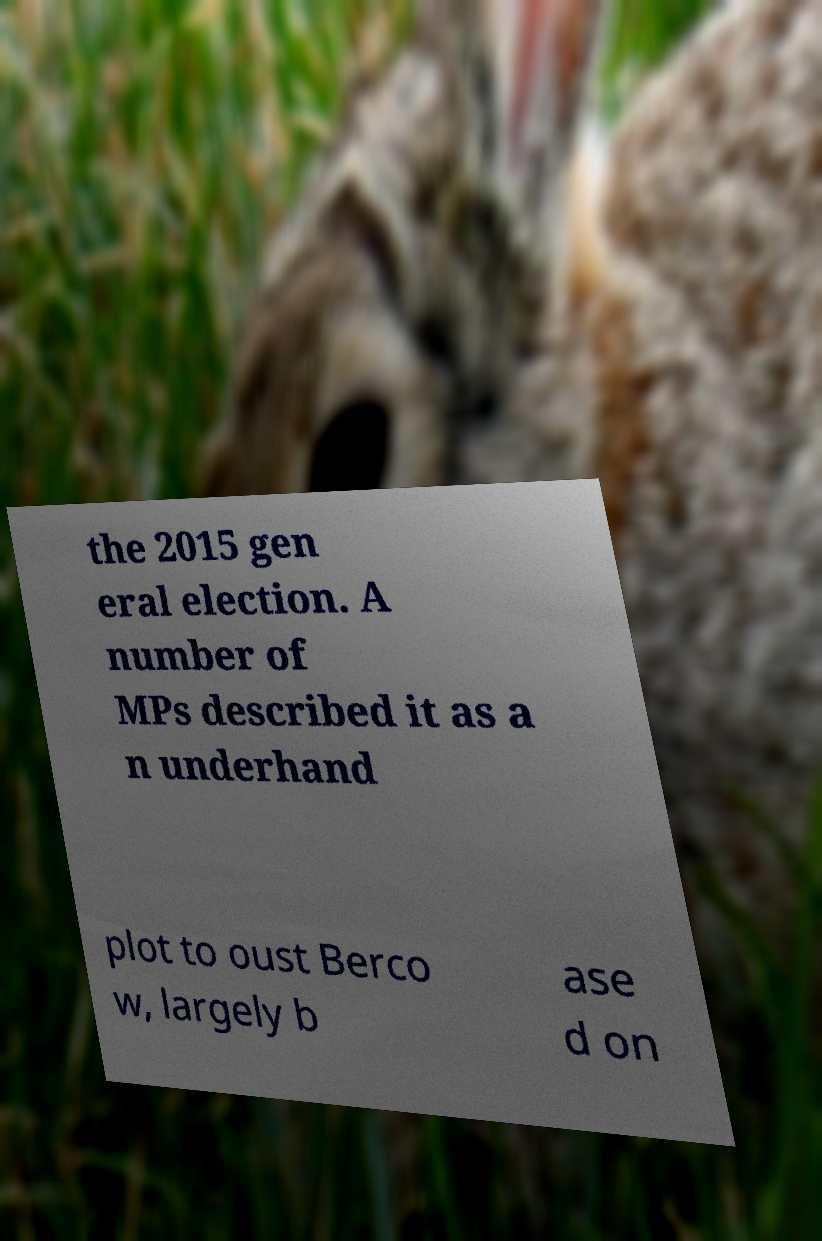For documentation purposes, I need the text within this image transcribed. Could you provide that? the 2015 gen eral election. A number of MPs described it as a n underhand plot to oust Berco w, largely b ase d on 